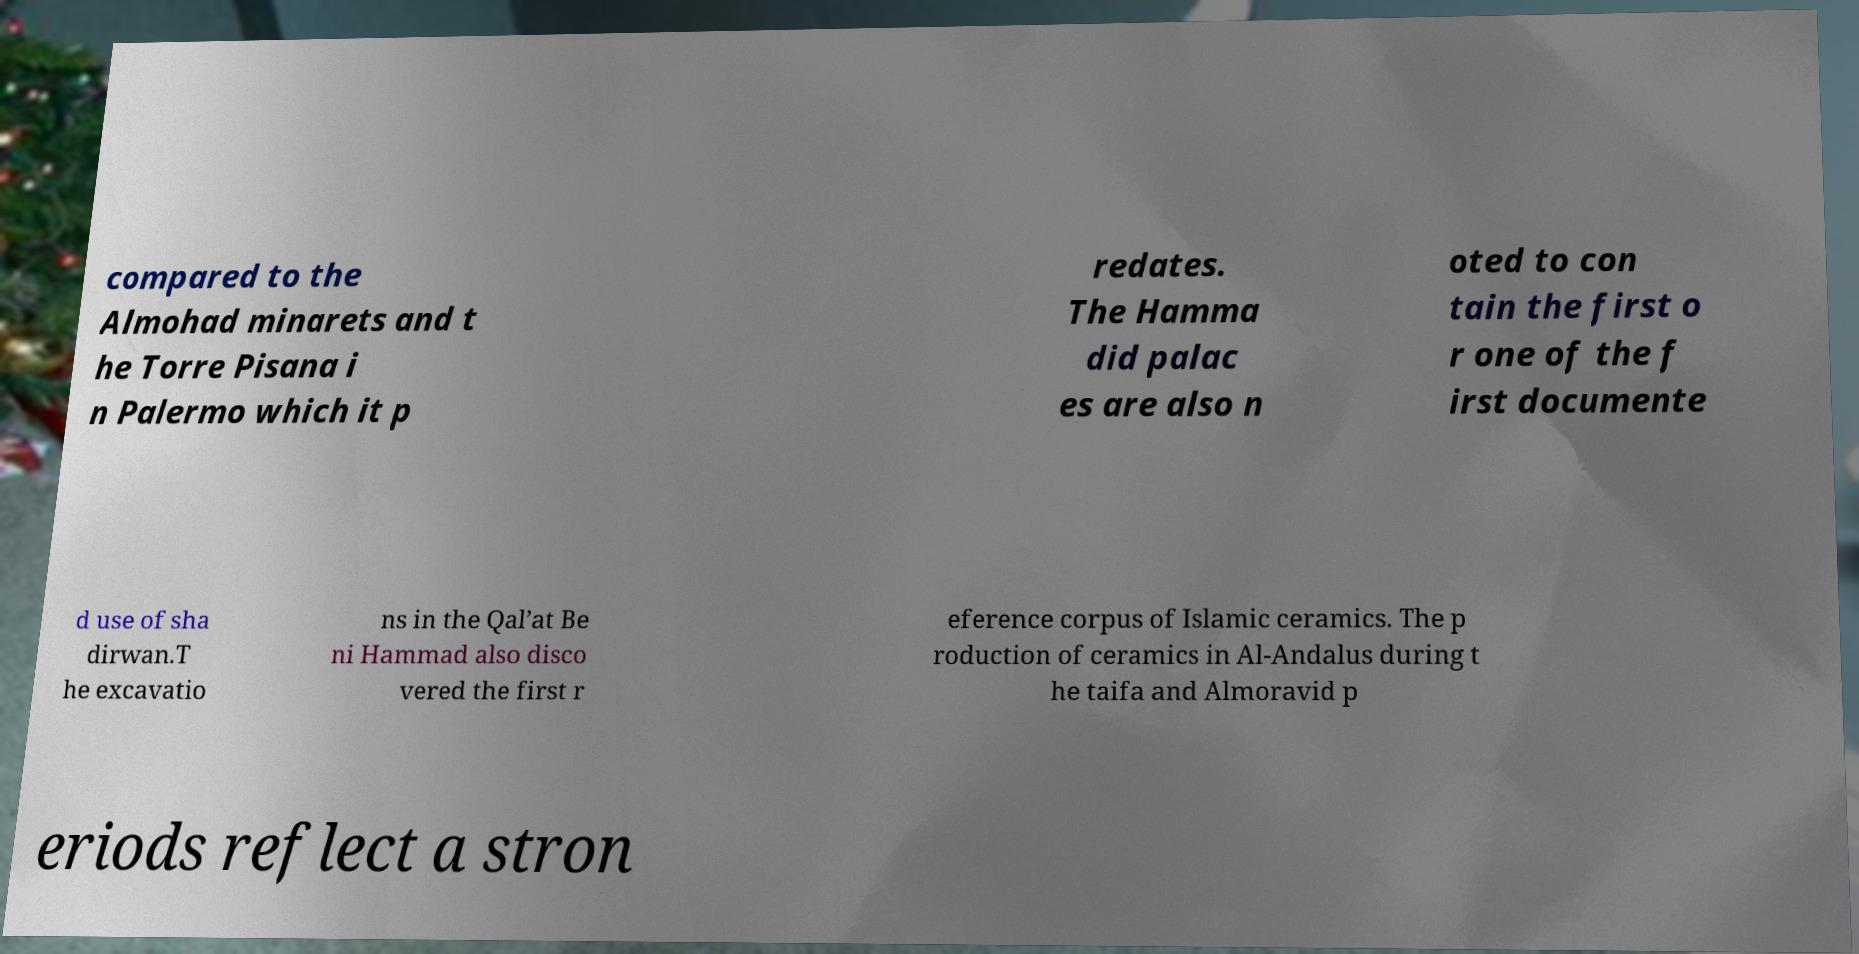Can you read and provide the text displayed in the image?This photo seems to have some interesting text. Can you extract and type it out for me? compared to the Almohad minarets and t he Torre Pisana i n Palermo which it p redates. The Hamma did palac es are also n oted to con tain the first o r one of the f irst documente d use of sha dirwan.T he excavatio ns in the Qal’at Be ni Hammad also disco vered the first r eference corpus of Islamic ceramics. The p roduction of ceramics in Al-Andalus during t he taifa and Almoravid p eriods reflect a stron 